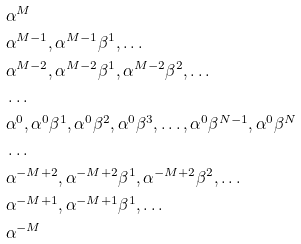<formula> <loc_0><loc_0><loc_500><loc_500>& \alpha ^ { M } \\ & \alpha ^ { M - 1 } , \alpha ^ { M - 1 } \beta ^ { 1 } , \dots \\ & \alpha ^ { M - 2 } , \alpha ^ { M - 2 } \beta ^ { 1 } , \alpha ^ { M - 2 } \beta ^ { 2 } , \dots \\ & \dots \\ & \alpha ^ { 0 } , \alpha ^ { 0 } \beta ^ { 1 } , \alpha ^ { 0 } \beta ^ { 2 } , \alpha ^ { 0 } \beta ^ { 3 } , \dots , \alpha ^ { 0 } \beta ^ { N - 1 } , \alpha ^ { 0 } \beta ^ { N } \\ & \dots \\ & \alpha ^ { - M + 2 } , \alpha ^ { - M + 2 } \beta ^ { 1 } , \alpha ^ { - M + 2 } \beta ^ { 2 } , \dots \\ & \alpha ^ { - M + 1 } , \alpha ^ { - M + 1 } \beta ^ { 1 } , \dots \\ & \alpha ^ { - M } \\</formula> 